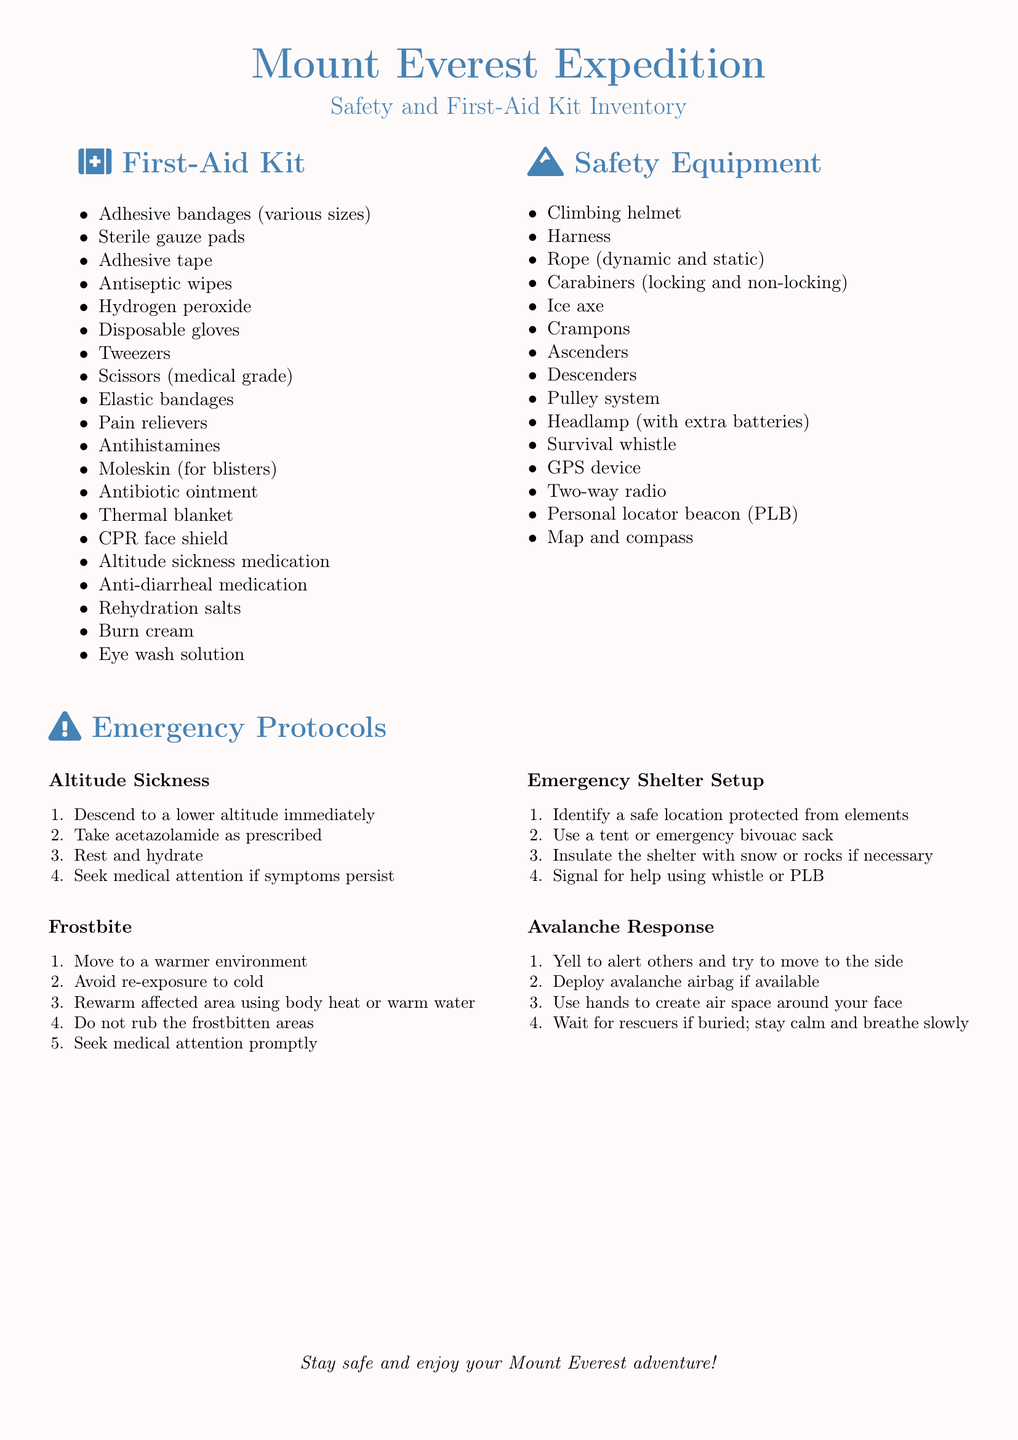What supplies are included in the First-Aid Kit? The document lists various supplies necessary for a First-Aid Kit for a Mount Everest expedition.
Answer: Adhesive bandages, sterile gauze pads, adhesive tape, antiseptic wipes, hydrogen peroxide, and more How many types of procedures are listed under Emergency Protocols? The document includes multiple procedures for dealing with emergencies, each addressing specific issues.
Answer: Four What is one recommended action for altitude sickness? The document suggests immediate actions to take when experiencing altitude sickness to ensure safety.
Answer: Descend to a lower altitude immediately Which safety equipment is essential for climbing? The section lists all essential equipment that climbers must carry to ensure their safety during the expedition.
Answer: Climbing helmet, harness, rope, ice axe, crampons, and more What should you use to signal for help during an emergency shelter setup? The document specifies ways to attract attention during an emergency, using available tools.
Answer: Whistle or PLB How should one respond if buried in an avalanche? The document provides steps to take in such dire situations, helping a climber survive.
Answer: Wait for rescuers if buried; stay calm and breathe slowly Which medication is included for altitude sickness? The contents of the First-Aid Kit include specific medications that address altitude-related issues encountered during expeditions.
Answer: Altitude sickness medication What is recommended to help with frostbite? The document outlines necessary steps to treat frostbite effectively, emphasizing safety.
Answer: Move to a warmer environment 